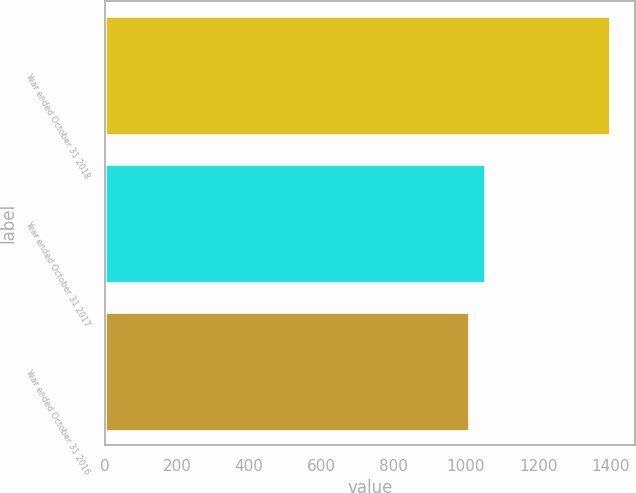Convert chart to OTSL. <chart><loc_0><loc_0><loc_500><loc_500><bar_chart><fcel>Year ended October 31 2018<fcel>Year ended October 31 2017<fcel>Year ended October 31 2016<nl><fcel>1398<fcel>1054<fcel>1009<nl></chart> 